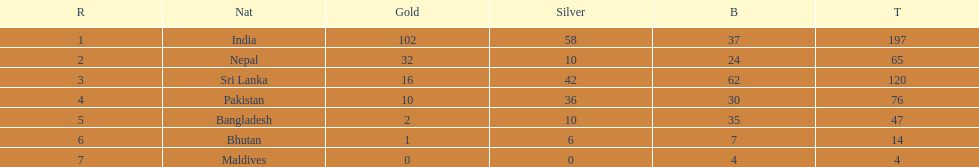I'm looking to parse the entire table for insights. Could you assist me with that? {'header': ['R', 'Nat', 'Gold', 'Silver', 'B', 'T'], 'rows': [['1', 'India', '102', '58', '37', '197'], ['2', 'Nepal', '32', '10', '24', '65'], ['3', 'Sri Lanka', '16', '42', '62', '120'], ['4', 'Pakistan', '10', '36', '30', '76'], ['5', 'Bangladesh', '2', '10', '35', '47'], ['6', 'Bhutan', '1', '6', '7', '14'], ['7', 'Maldives', '0', '0', '4', '4']]} How many countries have one more than 10 gold medals? 3. 